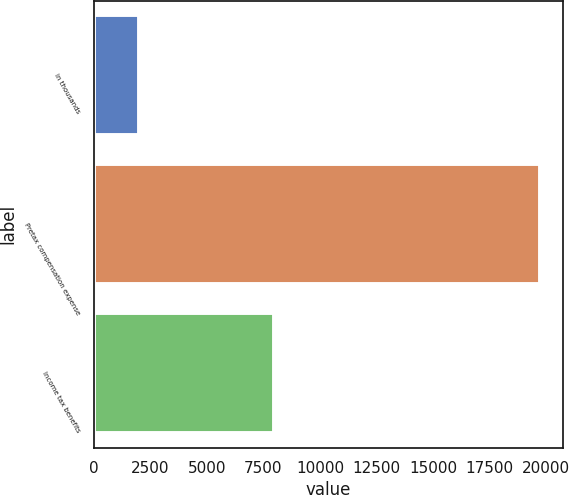Convert chart. <chart><loc_0><loc_0><loc_500><loc_500><bar_chart><fcel>in thousands<fcel>Pretax compensation expense<fcel>Income tax benefits<nl><fcel>2010<fcel>19746<fcel>7968<nl></chart> 